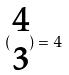Convert formula to latex. <formula><loc_0><loc_0><loc_500><loc_500>( \begin{matrix} 4 \\ 3 \end{matrix} ) = 4</formula> 